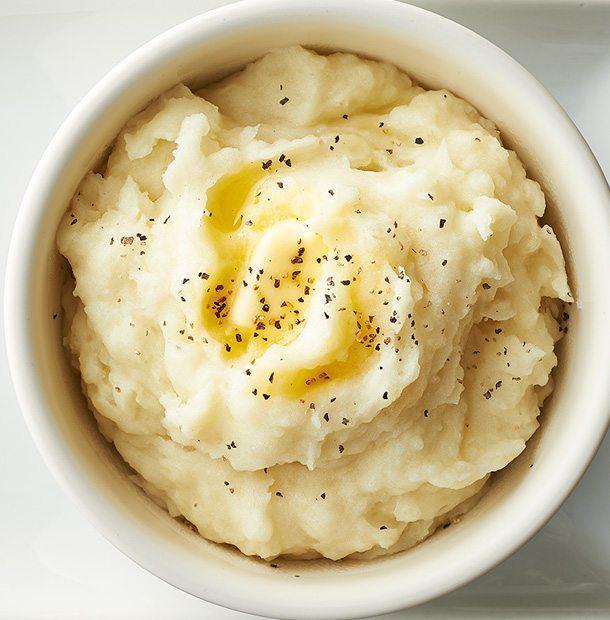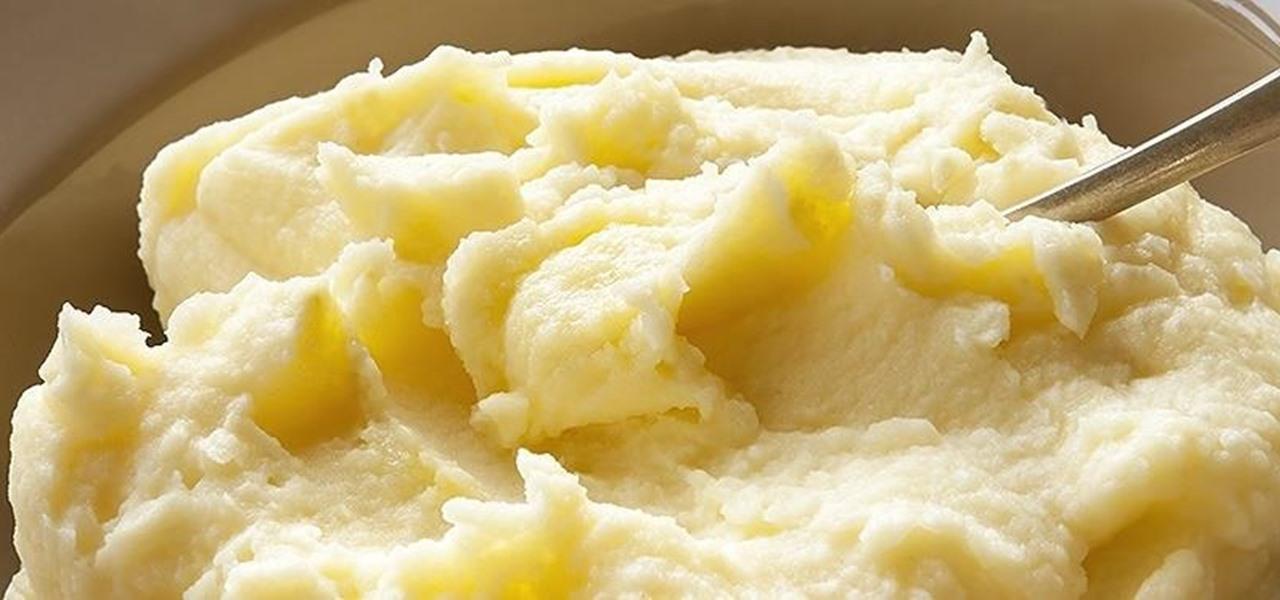The first image is the image on the left, the second image is the image on the right. For the images displayed, is the sentence "At least one image has a bowl of mashed potatoes, garnished with parsley, and parlest visible on the dark wooden surface beside the bowl." factually correct? Answer yes or no. No. The first image is the image on the left, the second image is the image on the right. Evaluate the accuracy of this statement regarding the images: "The mashed potatoes on the right have a spoon handle visibly sticking out of them". Is it true? Answer yes or no. Yes. 